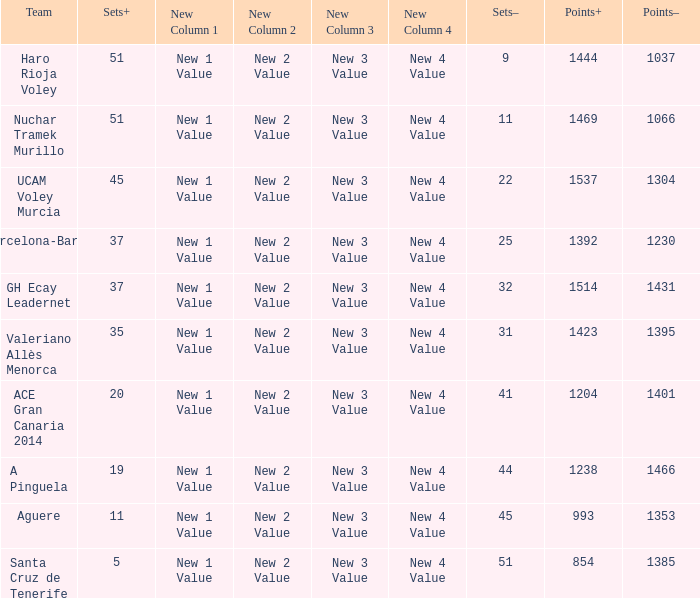What is the highest Points+ number when the Points- number is larger than 1385, a Sets+ number smaller than 37 and a Sets- number larger than 41? 1238.0. 